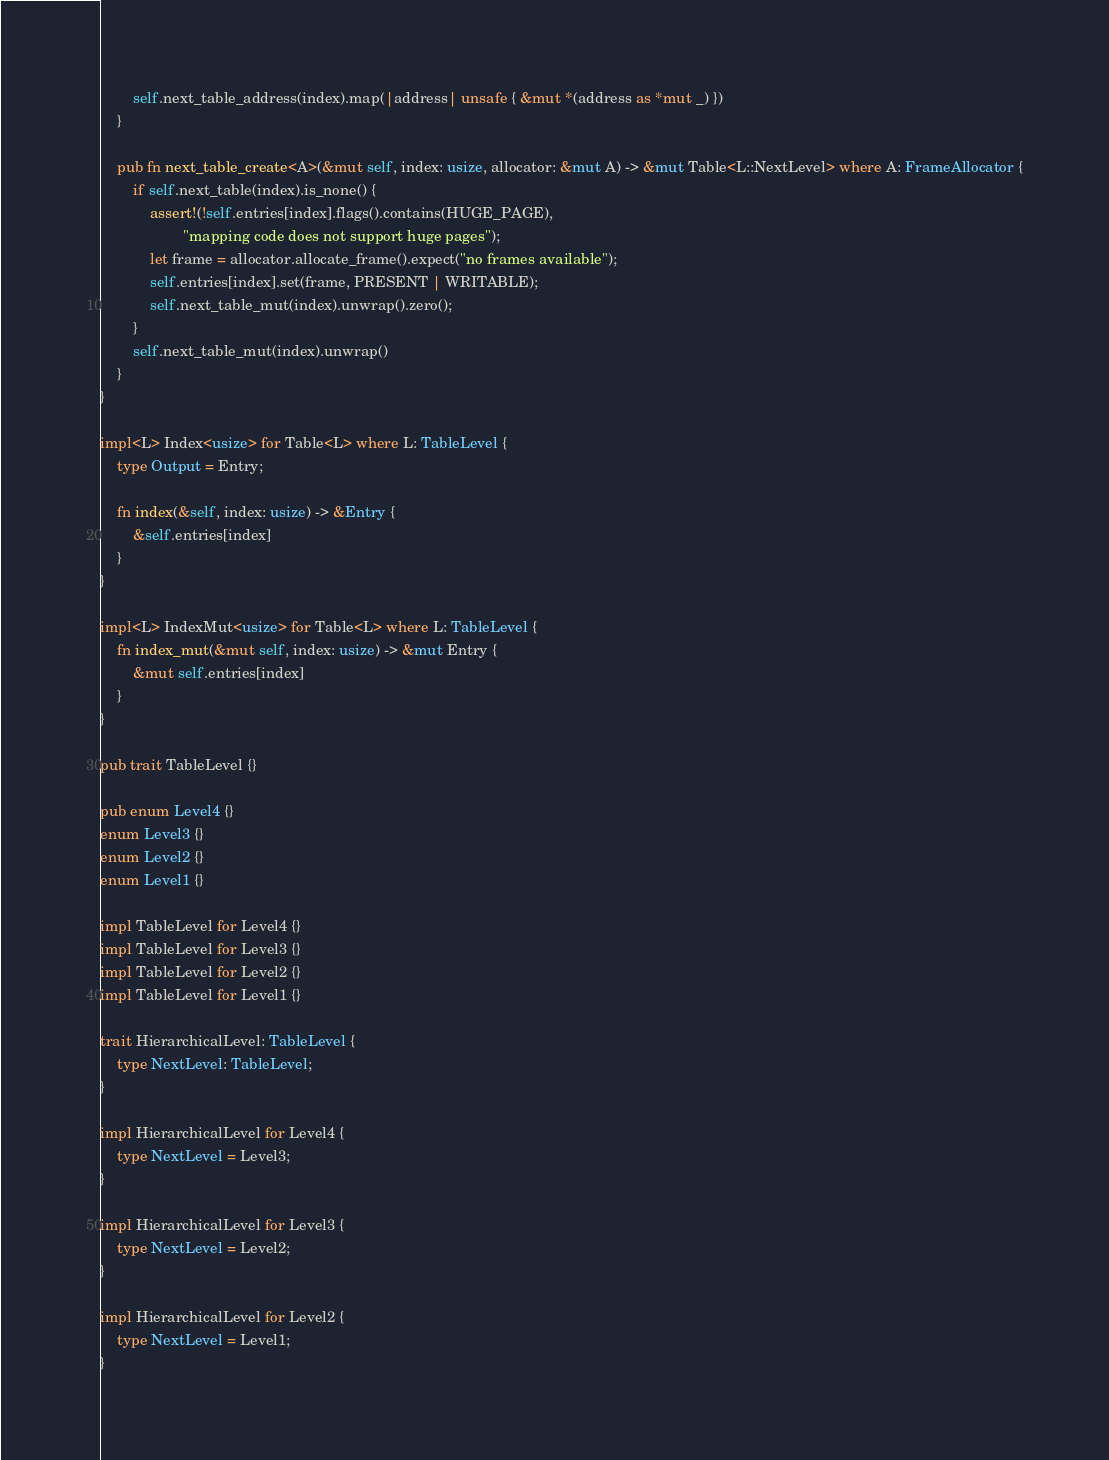<code> <loc_0><loc_0><loc_500><loc_500><_Rust_>        self.next_table_address(index).map(|address| unsafe { &mut *(address as *mut _) })
    }

    pub fn next_table_create<A>(&mut self, index: usize, allocator: &mut A) -> &mut Table<L::NextLevel> where A: FrameAllocator {
        if self.next_table(index).is_none() {
            assert!(!self.entries[index].flags().contains(HUGE_PAGE),
                    "mapping code does not support huge pages");
            let frame = allocator.allocate_frame().expect("no frames available");
            self.entries[index].set(frame, PRESENT | WRITABLE);
            self.next_table_mut(index).unwrap().zero();
        }
        self.next_table_mut(index).unwrap()
    }
}

impl<L> Index<usize> for Table<L> where L: TableLevel {
    type Output = Entry;

    fn index(&self, index: usize) -> &Entry {
        &self.entries[index]
    }
}

impl<L> IndexMut<usize> for Table<L> where L: TableLevel {
    fn index_mut(&mut self, index: usize) -> &mut Entry {
        &mut self.entries[index]
    }
}

pub trait TableLevel {}

pub enum Level4 {}
enum Level3 {}
enum Level2 {}
enum Level1 {}

impl TableLevel for Level4 {}
impl TableLevel for Level3 {}
impl TableLevel for Level2 {}
impl TableLevel for Level1 {}

trait HierarchicalLevel: TableLevel {
    type NextLevel: TableLevel;
}

impl HierarchicalLevel for Level4 {
    type NextLevel = Level3;
}

impl HierarchicalLevel for Level3 {
    type NextLevel = Level2;
}

impl HierarchicalLevel for Level2 {
    type NextLevel = Level1;
}</code> 